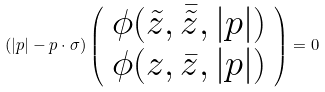Convert formula to latex. <formula><loc_0><loc_0><loc_500><loc_500>( | { p } | - { p } \cdot { \sigma } ) \left ( \begin{array} { c } \phi ( \tilde { z } , \bar { \tilde { z } } , | { p } | ) \\ \phi ( z , \bar { z } , | { p } | ) \end{array} \right ) = 0</formula> 